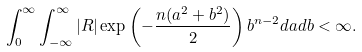<formula> <loc_0><loc_0><loc_500><loc_500>\int _ { 0 } ^ { \infty } \int _ { - \infty } ^ { \infty } | R | \exp \left ( - \frac { n ( a ^ { 2 } + b ^ { 2 } ) } { 2 } \right ) b ^ { n - 2 } d a d b < \infty .</formula> 